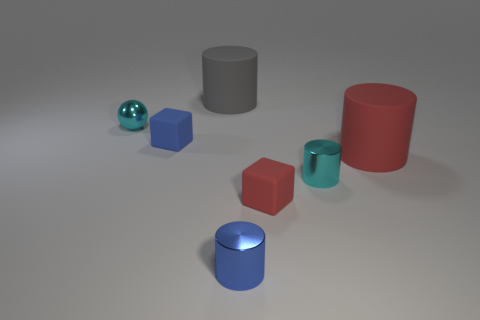Add 1 big cyan metallic spheres. How many objects exist? 8 Subtract all red cylinders. How many cylinders are left? 3 Subtract all purple cylinders. Subtract all gray balls. How many cylinders are left? 4 Add 2 big gray objects. How many big gray objects are left? 3 Add 7 small blue cylinders. How many small blue cylinders exist? 8 Subtract 0 purple blocks. How many objects are left? 7 Subtract all balls. How many objects are left? 6 Subtract all rubber objects. Subtract all big rubber objects. How many objects are left? 1 